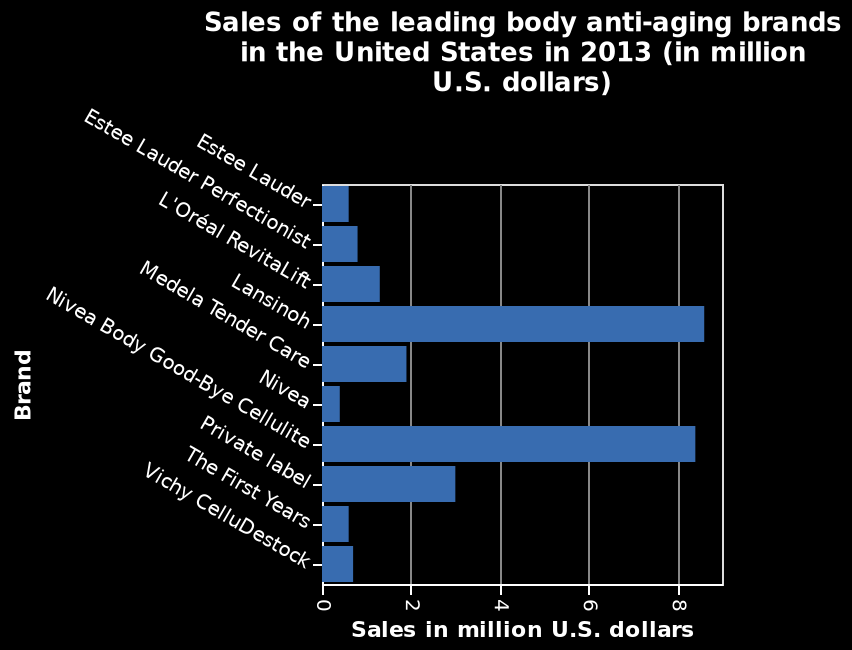<image>
Offer a thorough analysis of the image. Lansinoh is the most popular and raked in over 8 million sales in 2013, followed closely by Nivea Body Good-Bye Cellulite. Private label is the next highest with around 3 million and all others made under 2 million sales that year. How many brands made sales under 2 million in 2013?  All other brands, except for Lansinoh, Nivea Body Good-Bye Cellulite, and private label, made sales under 2 million in 2013. Which brand closely followed Lansinoh in terms of sales in 2013?  Nivea Body Good-Bye Cellulite closely followed Lansinoh in terms of sales in 2013. Did Lansinoh manage to rack up over 8 million sales in 2013? No.Lansinoh is the most popular and raked in over 8 million sales in 2013, followed closely by Nivea Body Good-Bye Cellulite. Private label is the next highest with around 3 million and all others made under 2 million sales that year. 